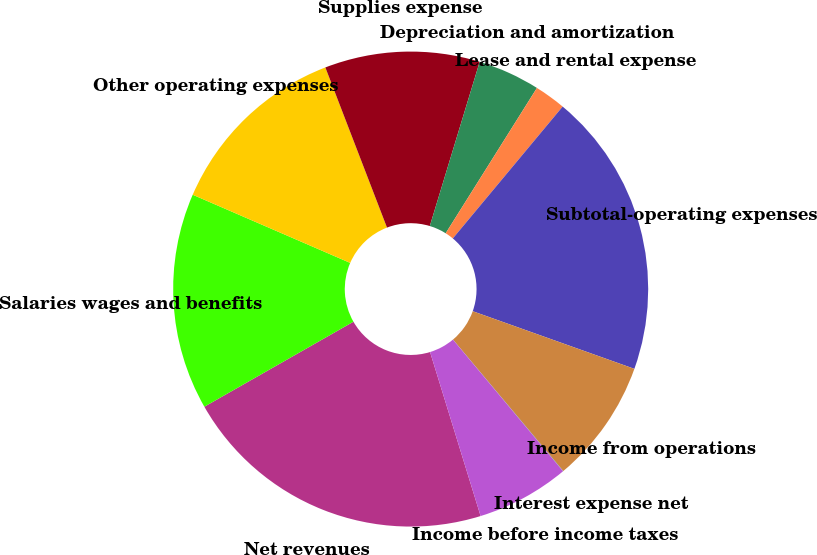Convert chart. <chart><loc_0><loc_0><loc_500><loc_500><pie_chart><fcel>Net revenues<fcel>Salaries wages and benefits<fcel>Other operating expenses<fcel>Supplies expense<fcel>Depreciation and amortization<fcel>Lease and rental expense<fcel>Subtotal-operating expenses<fcel>Income from operations<fcel>Interest expense net<fcel>Income before income taxes<nl><fcel>21.51%<fcel>14.75%<fcel>12.65%<fcel>10.54%<fcel>4.23%<fcel>2.13%<fcel>19.4%<fcel>8.44%<fcel>0.02%<fcel>6.33%<nl></chart> 